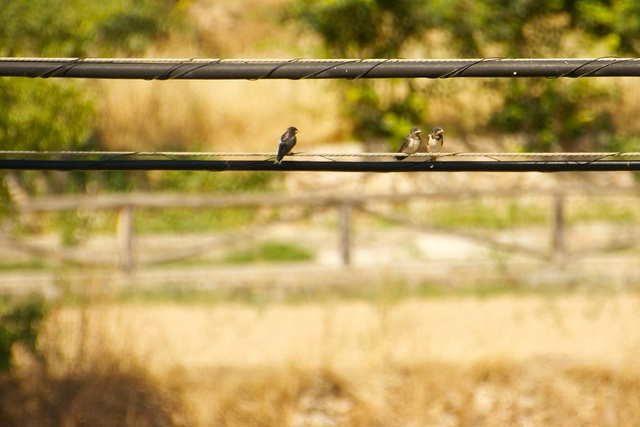Describe the objects in this image and their specific colors. I can see bird in olive and tan tones, bird in olive, black, and gray tones, and bird in olive and tan tones in this image. 